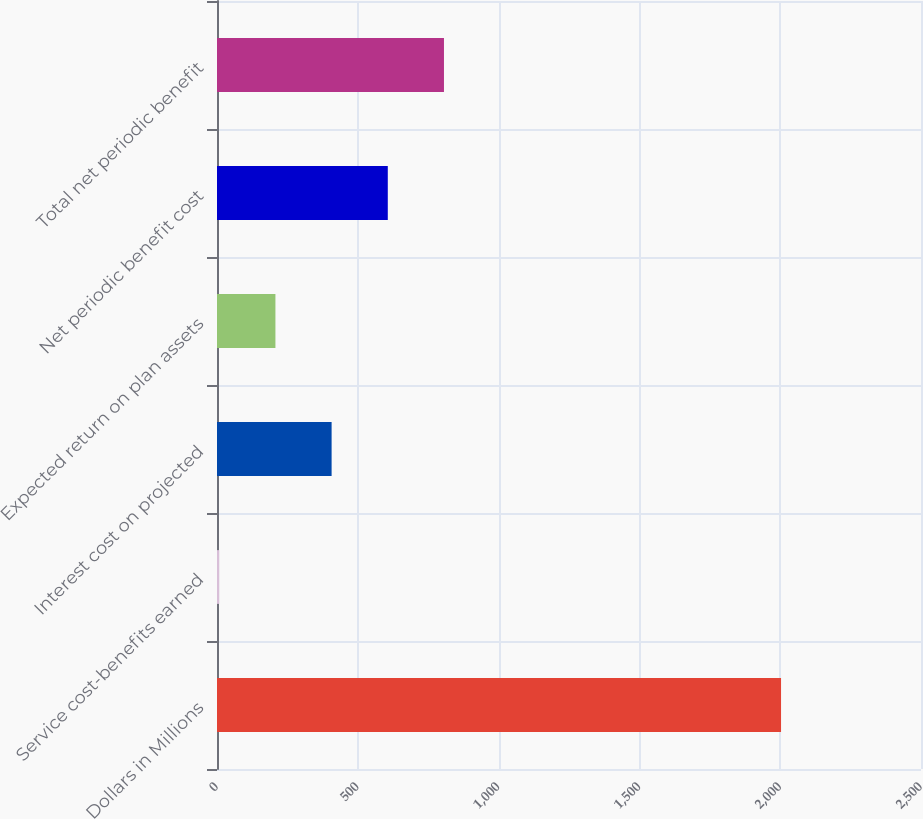Convert chart to OTSL. <chart><loc_0><loc_0><loc_500><loc_500><bar_chart><fcel>Dollars in Millions<fcel>Service cost-benefits earned<fcel>Interest cost on projected<fcel>Expected return on plan assets<fcel>Net periodic benefit cost<fcel>Total net periodic benefit<nl><fcel>2003<fcel>8<fcel>407<fcel>207.5<fcel>606.5<fcel>806<nl></chart> 